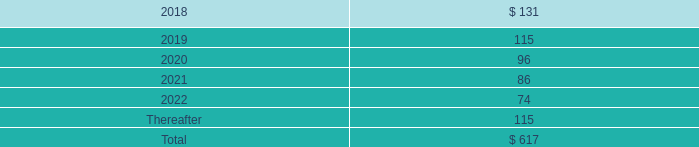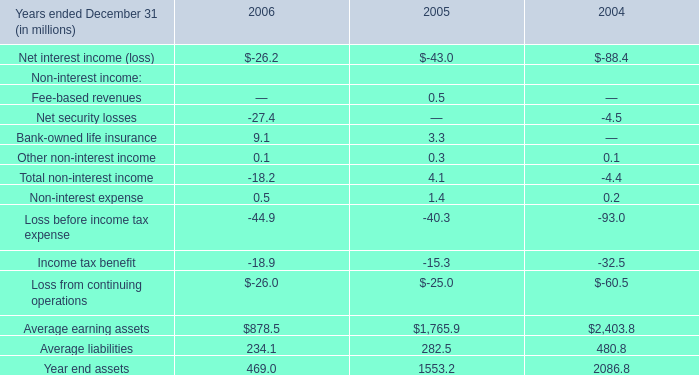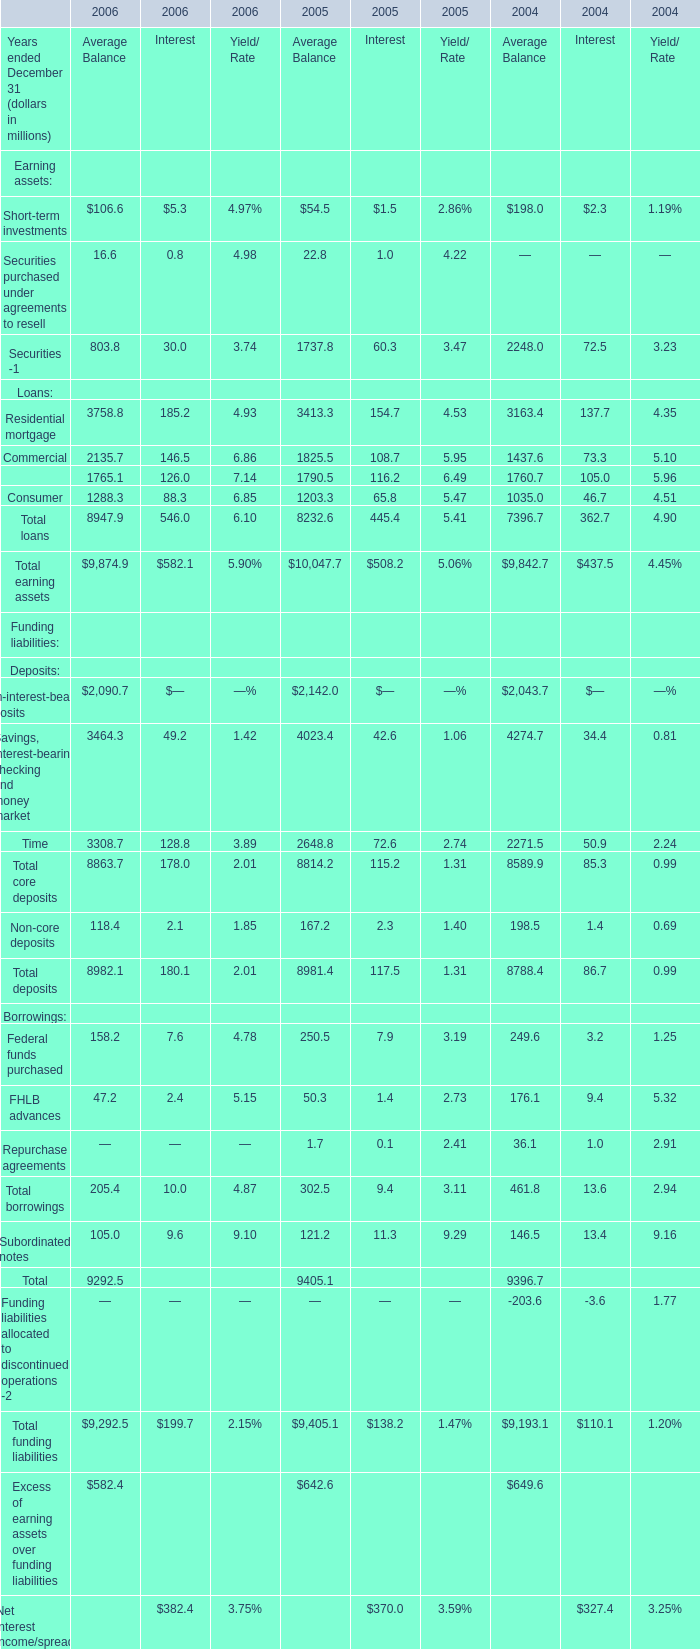When does Average Balance of Short-term investments increase between 2005 and 2006? 
Answer: 2006. 